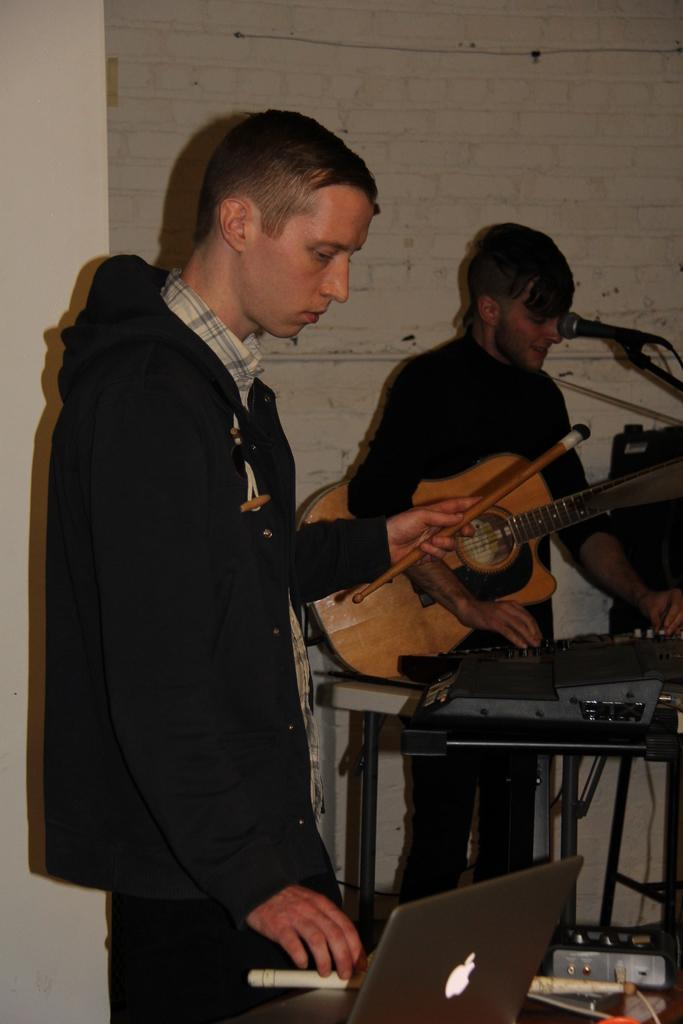How many people are in the image? There are two persons in the image. What is one person doing in the image? One person is playing a guitar. What object is present for amplifying sound in the image? There is a microphone (mike) in the image. What electronic device is visible in the image? There is a laptop in the image. What can be seen in the background of the image? There is a wall in the background of the image. What type of vest is the person wearing while playing the guitar in the image? There is no mention of a vest in the image, and the person is not wearing one. 